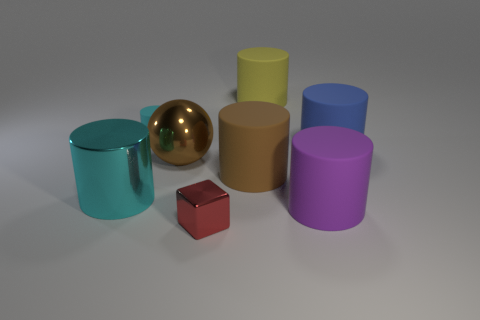There is a large matte thing that is to the left of the yellow cylinder; does it have the same shape as the big matte thing right of the purple cylinder?
Offer a terse response. Yes. Are there any big brown shiny cylinders?
Your response must be concise. No. There is a metal cylinder that is the same size as the sphere; what color is it?
Offer a terse response. Cyan. What number of tiny cyan matte objects are the same shape as the big purple object?
Offer a terse response. 1. Is the big thing on the right side of the large purple matte object made of the same material as the small red thing?
Your answer should be compact. No. How many cubes are big purple objects or small metallic things?
Provide a succinct answer. 1. What is the shape of the shiny thing that is in front of the big matte cylinder that is in front of the big matte cylinder that is to the left of the large yellow rubber object?
Your answer should be very brief. Cube. The other thing that is the same color as the tiny matte object is what shape?
Your response must be concise. Cylinder. How many purple things are the same size as the metal block?
Make the answer very short. 0. Are there any red cubes in front of the matte cylinder that is in front of the large cyan metal cylinder?
Ensure brevity in your answer.  Yes. 